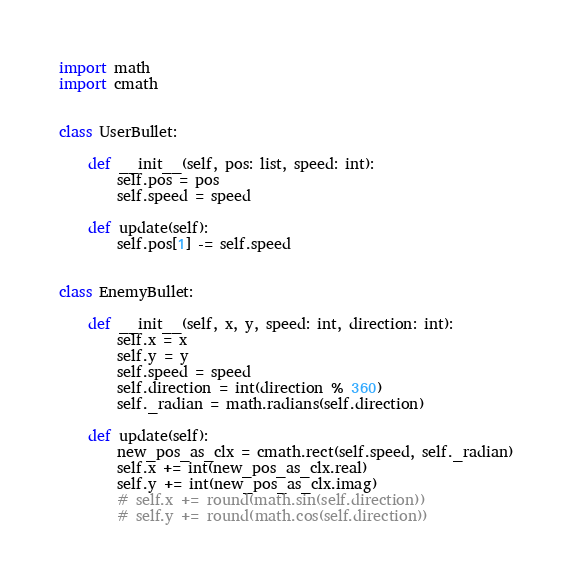<code> <loc_0><loc_0><loc_500><loc_500><_Python_>import math
import cmath


class UserBullet:

    def __init__(self, pos: list, speed: int):
        self.pos = pos
        self.speed = speed

    def update(self):
        self.pos[1] -= self.speed


class EnemyBullet:

    def __init__(self, x, y, speed: int, direction: int):
        self.x = x
        self.y = y
        self.speed = speed
        self.direction = int(direction % 360)
        self._radian = math.radians(self.direction)

    def update(self):
        new_pos_as_clx = cmath.rect(self.speed, self._radian)
        self.x += int(new_pos_as_clx.real)
        self.y += int(new_pos_as_clx.imag)
        # self.x += round(math.sin(self.direction))
        # self.y += round(math.cos(self.direction))
</code> 